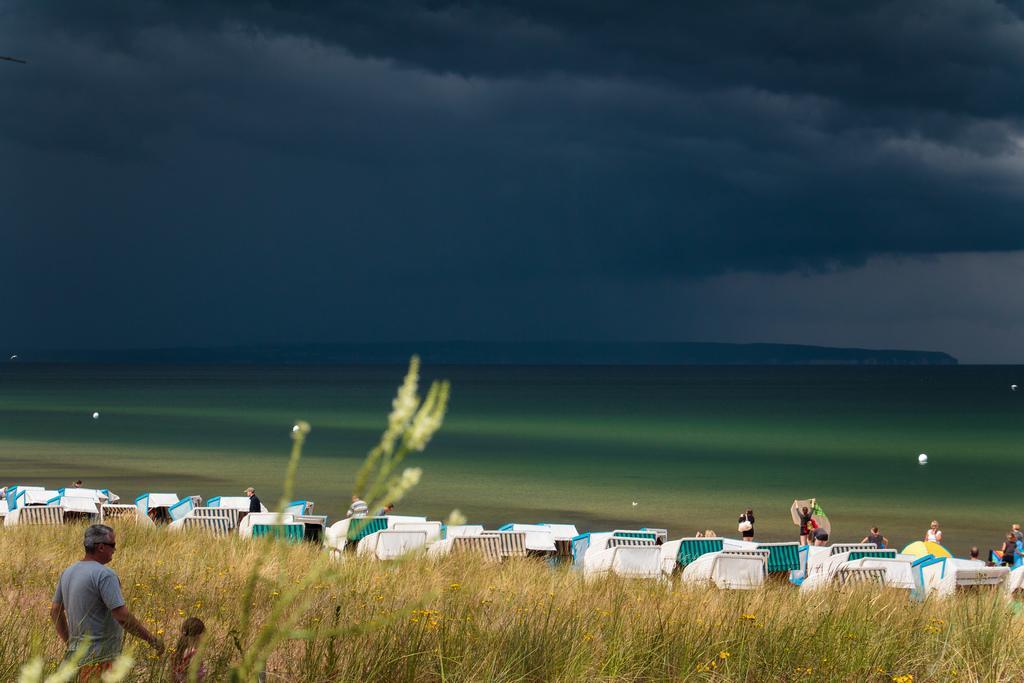Can you describe this image briefly? In this picture there are objects and there are group of people standing. On the left side of the image there are two people and there are plants and flowers. At the back there is water and there might be mountains. At the top there are clouds and their might be lanterns. 